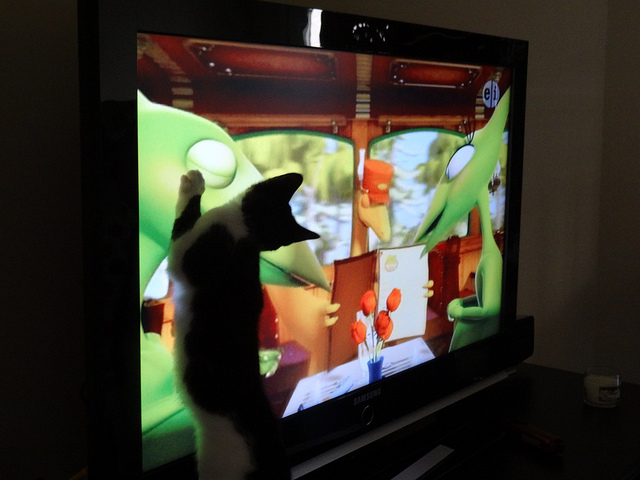<image>What sport is the cat watching? The cat is not watching any sport. It can be seen watching a cartoon. Which pterodactyl is female? I don't know which pterodactyl is female. It can be the one on the right or the left, or even both. What sport is the cat watching? The cat is not watching any sport. It is watching cartoons. Which pterodactyl is female? I don't know which pterodactyl is female. It could be either the right one, the green one, or the one on the left. 